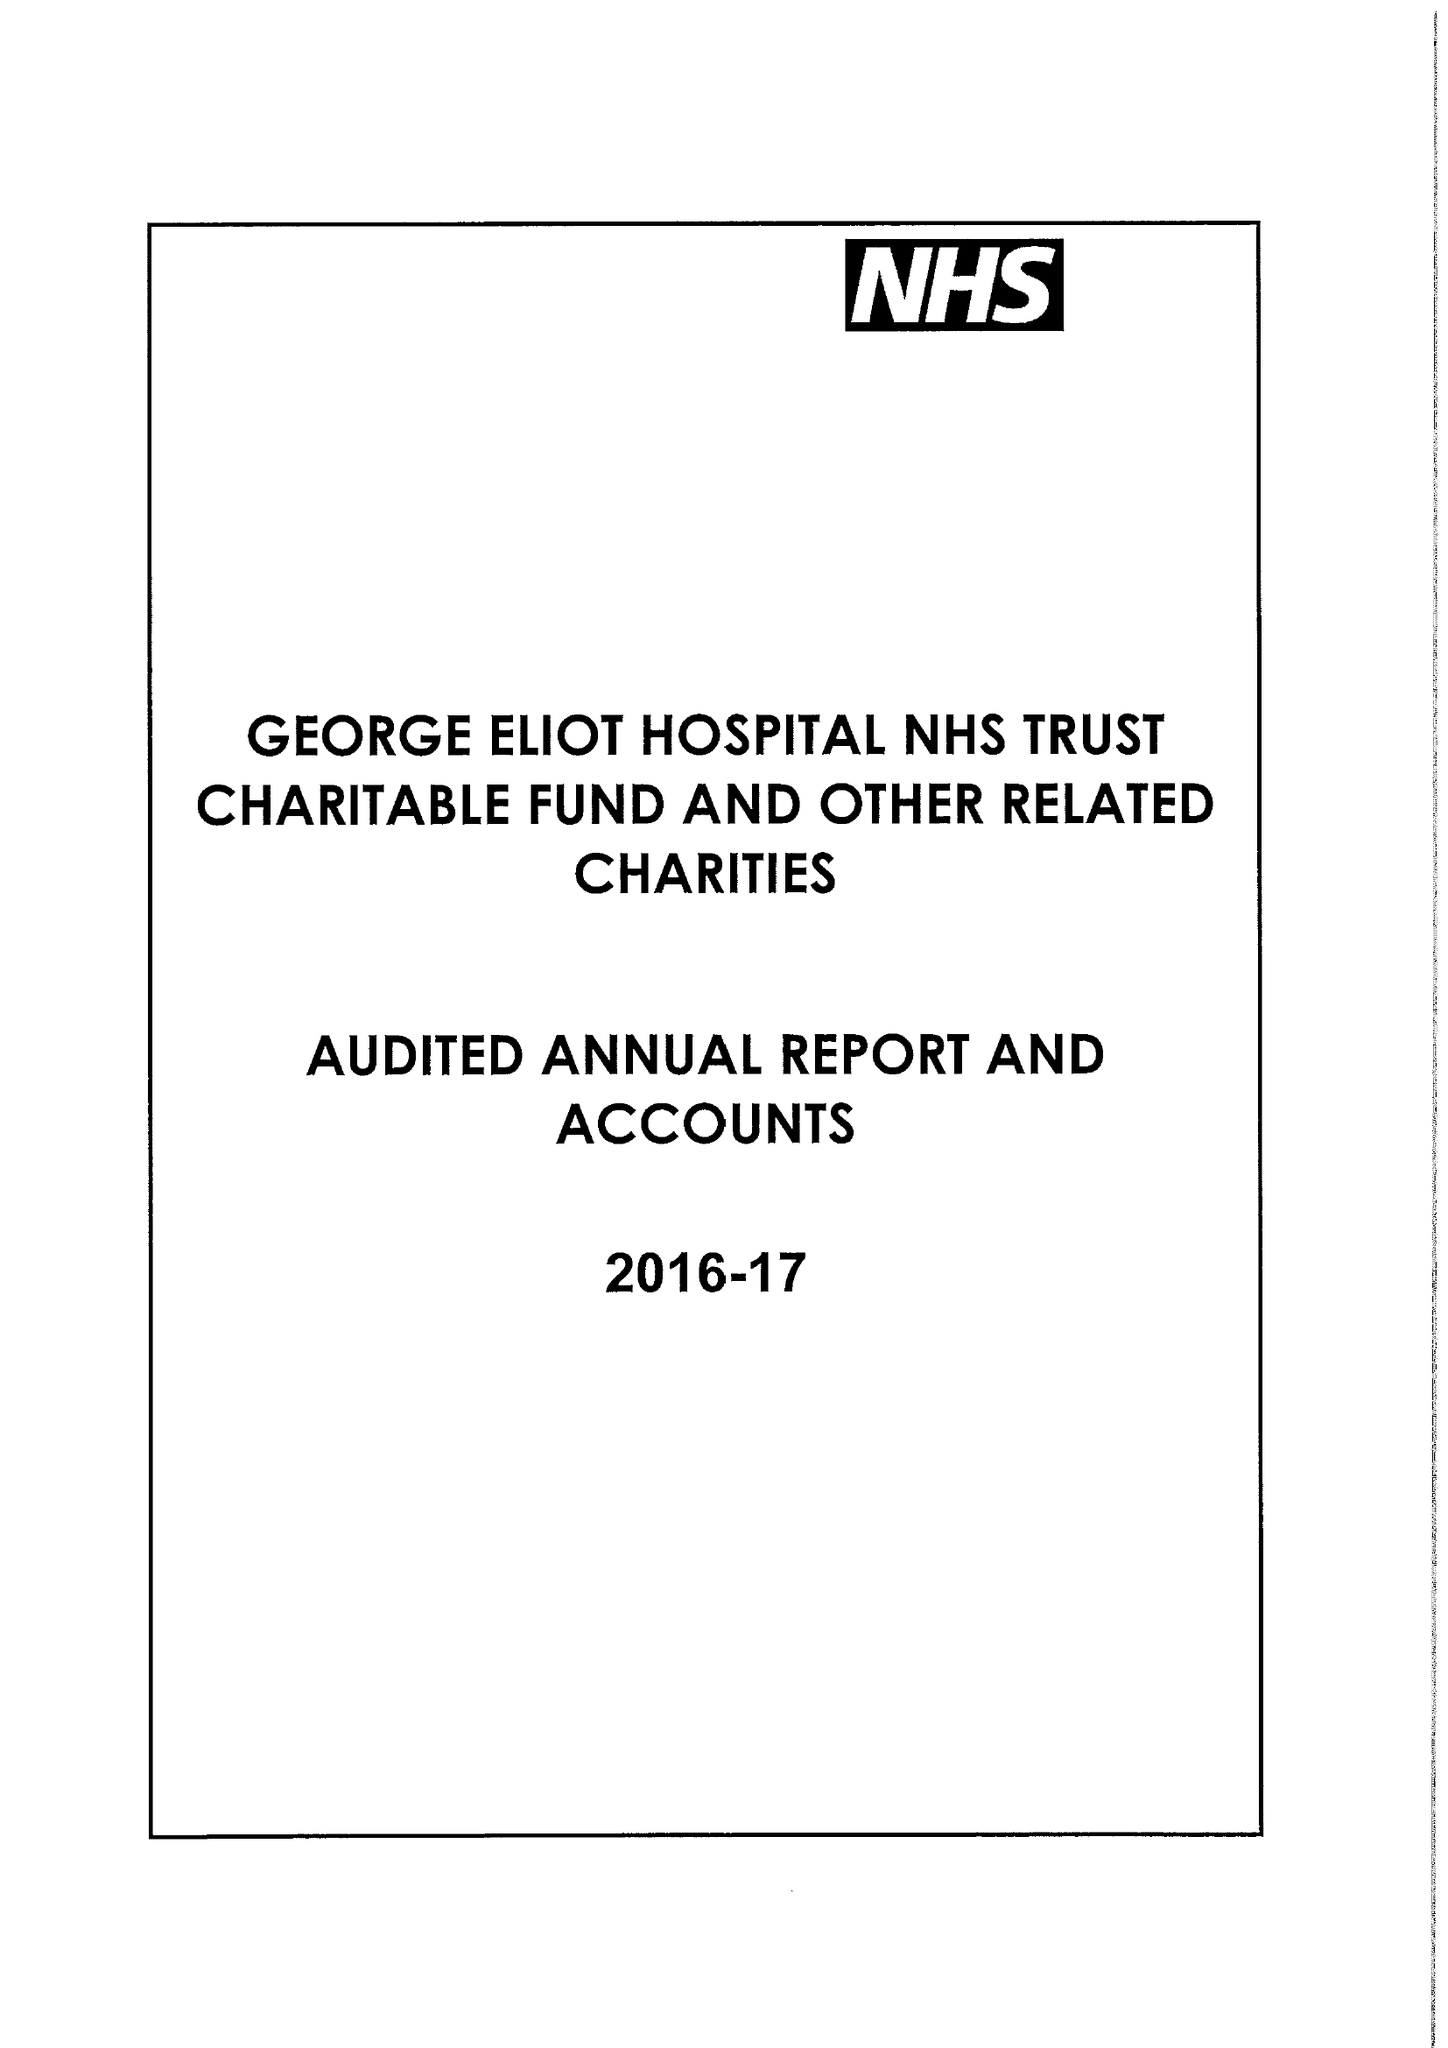What is the value for the charity_name?
Answer the question using a single word or phrase. George Eliot Hospital Nhs Trust Charitable Fund and Other Related Charities 